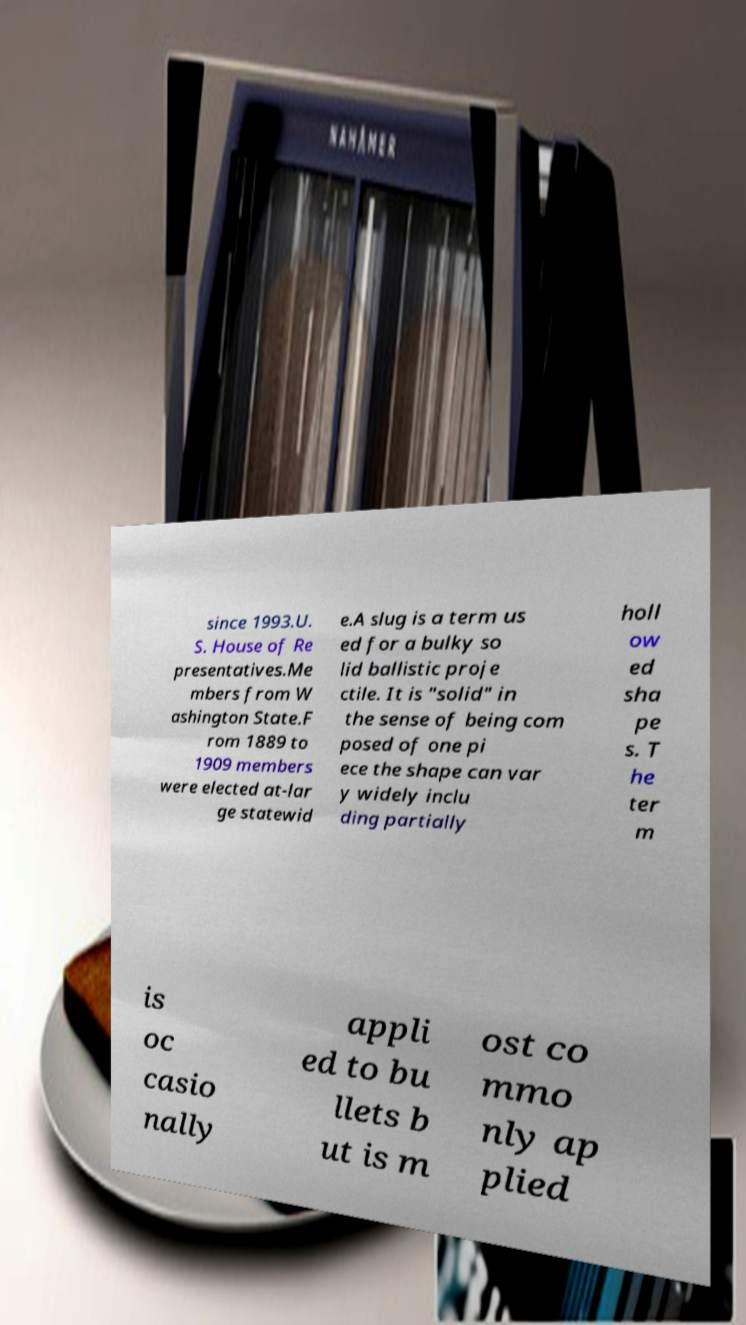I need the written content from this picture converted into text. Can you do that? since 1993.U. S. House of Re presentatives.Me mbers from W ashington State.F rom 1889 to 1909 members were elected at-lar ge statewid e.A slug is a term us ed for a bulky so lid ballistic proje ctile. It is "solid" in the sense of being com posed of one pi ece the shape can var y widely inclu ding partially holl ow ed sha pe s. T he ter m is oc casio nally appli ed to bu llets b ut is m ost co mmo nly ap plied 